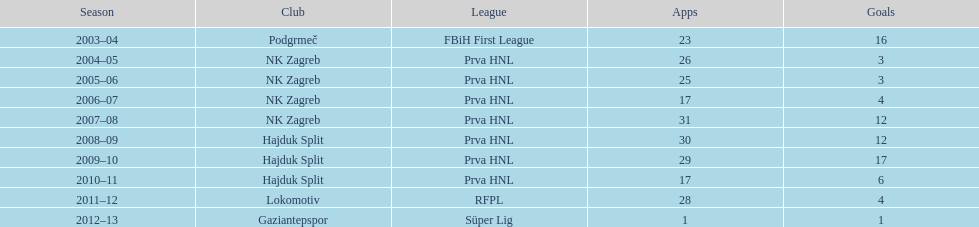Could you parse the entire table as a dict? {'header': ['Season', 'Club', 'League', 'Apps', 'Goals'], 'rows': [['2003–04', 'Podgrmeč', 'FBiH First League', '23', '16'], ['2004–05', 'NK Zagreb', 'Prva HNL', '26', '3'], ['2005–06', 'NK Zagreb', 'Prva HNL', '25', '3'], ['2006–07', 'NK Zagreb', 'Prva HNL', '17', '4'], ['2007–08', 'NK Zagreb', 'Prva HNL', '31', '12'], ['2008–09', 'Hajduk Split', 'Prva HNL', '30', '12'], ['2009–10', 'Hajduk Split', 'Prva HNL', '29', '17'], ['2010–11', 'Hajduk Split', 'Prva HNL', '17', '6'], ['2011–12', 'Lokomotiv', 'RFPL', '28', '4'], ['2012–13', 'Gaziantepspor', 'Süper Lig', '1', '1']]} What is the highest number of goals scored by senijad ibri&#269;i&#263; in a season? 35. 